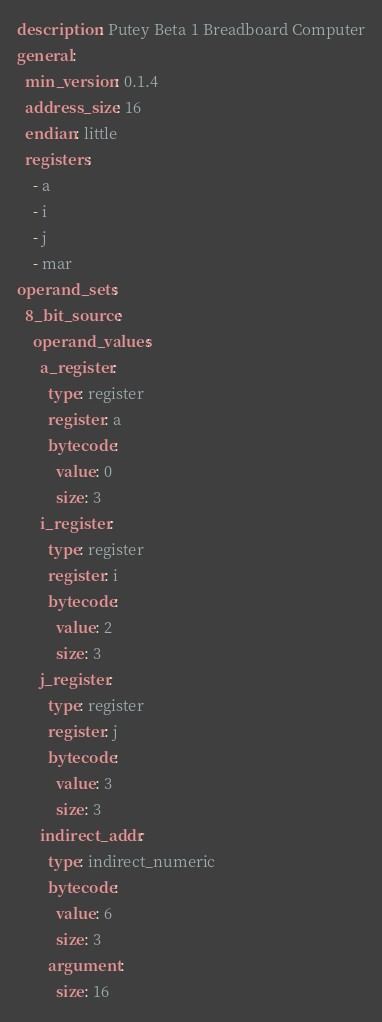Convert code to text. <code><loc_0><loc_0><loc_500><loc_500><_YAML_>description: Putey Beta 1 Breadboard Computer
general:
  min_version: 0.1.4
  address_size: 16
  endian: little
  registers:
    - a
    - i
    - j
    - mar
operand_sets:
  8_bit_source:
    operand_values:
      a_register:
        type: register
        register: a
        bytecode:
          value: 0
          size: 3
      i_register:
        type: register
        register: i
        bytecode:
          value: 2
          size: 3
      j_register:
        type: register
        register: j
        bytecode:
          value: 3
          size: 3
      indirect_addr:
        type: indirect_numeric
        bytecode:
          value: 6
          size: 3
        argument:
          size: 16</code> 